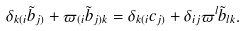Convert formula to latex. <formula><loc_0><loc_0><loc_500><loc_500>\delta _ { k ( i } \tilde { b } _ { j ) } + \varpi _ { ( i } \tilde { b } _ { j ) k } = \delta _ { k ( i } c _ { j ) } + \delta _ { i j } \varpi ^ { l } \tilde { b } _ { l k } .</formula> 